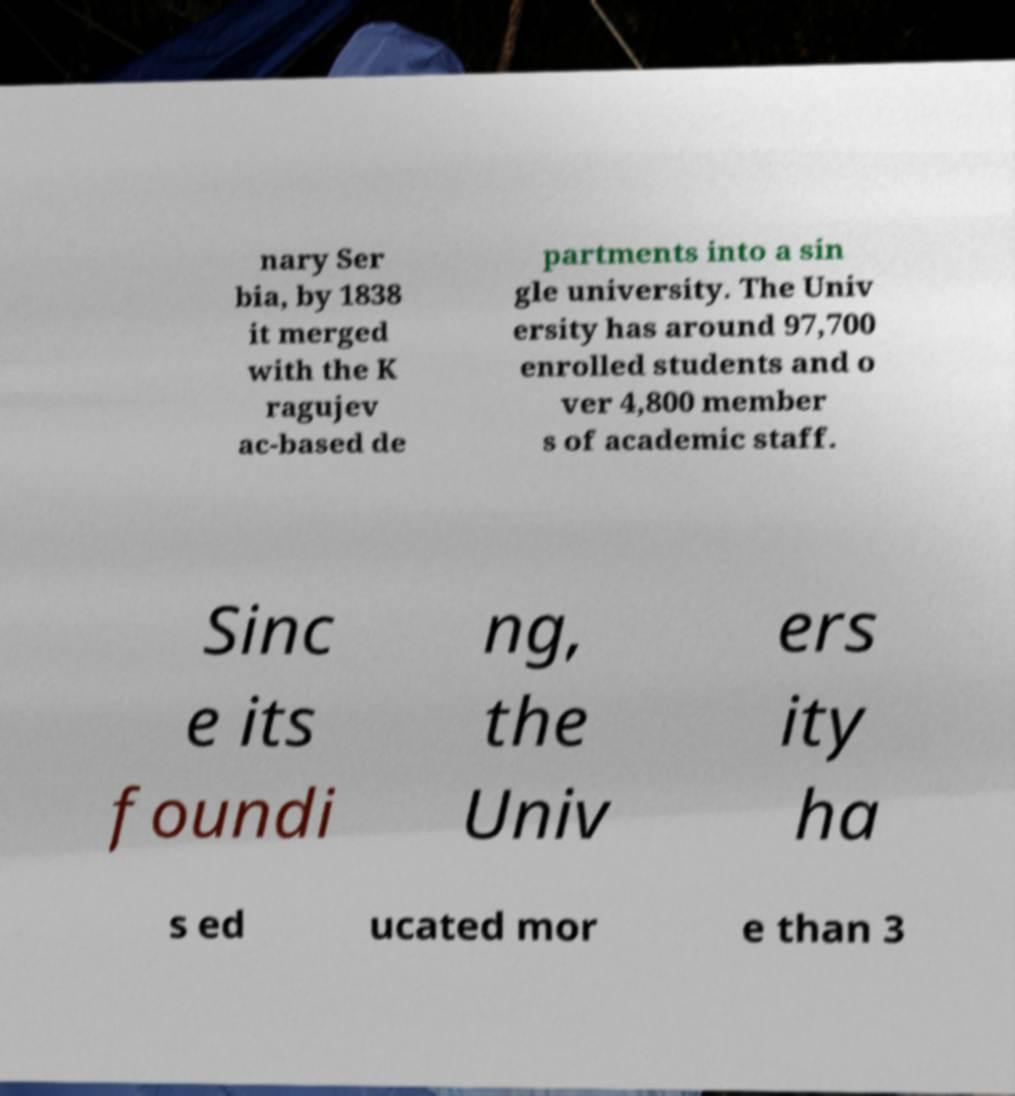Can you accurately transcribe the text from the provided image for me? nary Ser bia, by 1838 it merged with the K ragujev ac-based de partments into a sin gle university. The Univ ersity has around 97,700 enrolled students and o ver 4,800 member s of academic staff. Sinc e its foundi ng, the Univ ers ity ha s ed ucated mor e than 3 